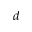Convert formula to latex. <formula><loc_0><loc_0><loc_500><loc_500>^ { d }</formula> 